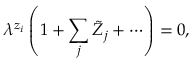<formula> <loc_0><loc_0><loc_500><loc_500>\lambda ^ { z _ { i } } \left ( 1 + \sum _ { j } \tilde { Z } _ { j } + \cdots \right ) = 0 ,</formula> 